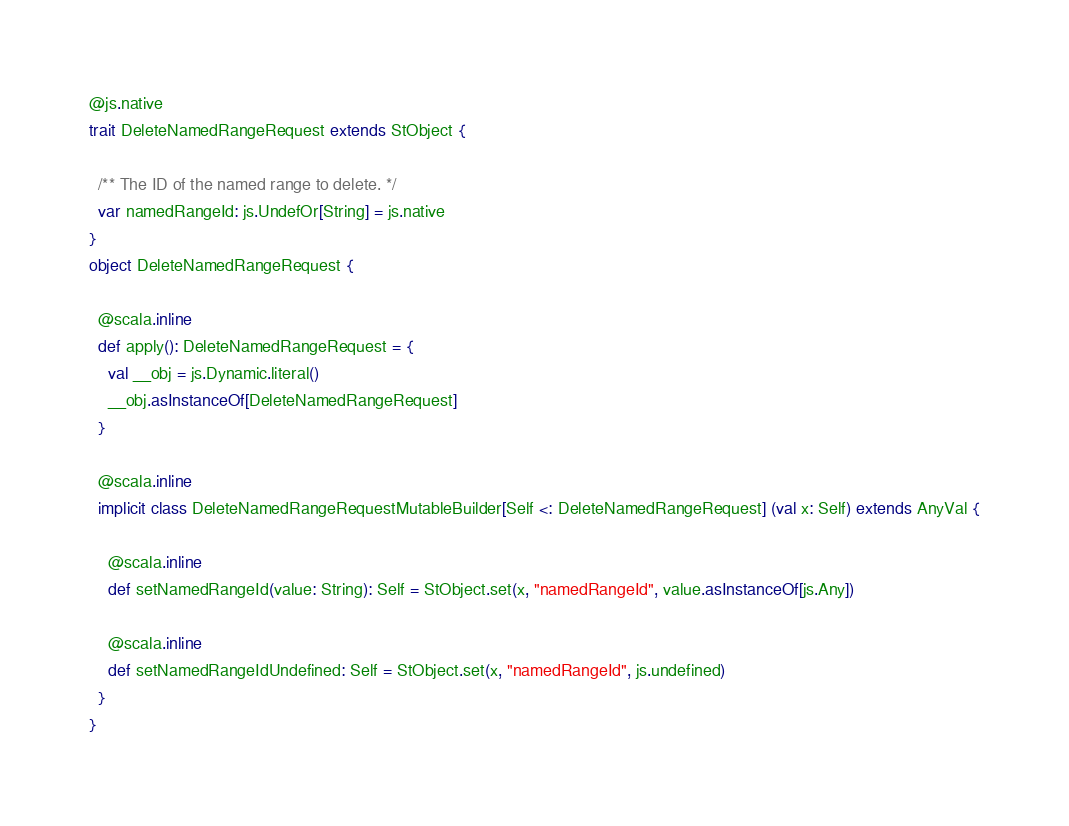Convert code to text. <code><loc_0><loc_0><loc_500><loc_500><_Scala_>
@js.native
trait DeleteNamedRangeRequest extends StObject {
  
  /** The ID of the named range to delete. */
  var namedRangeId: js.UndefOr[String] = js.native
}
object DeleteNamedRangeRequest {
  
  @scala.inline
  def apply(): DeleteNamedRangeRequest = {
    val __obj = js.Dynamic.literal()
    __obj.asInstanceOf[DeleteNamedRangeRequest]
  }
  
  @scala.inline
  implicit class DeleteNamedRangeRequestMutableBuilder[Self <: DeleteNamedRangeRequest] (val x: Self) extends AnyVal {
    
    @scala.inline
    def setNamedRangeId(value: String): Self = StObject.set(x, "namedRangeId", value.asInstanceOf[js.Any])
    
    @scala.inline
    def setNamedRangeIdUndefined: Self = StObject.set(x, "namedRangeId", js.undefined)
  }
}
</code> 